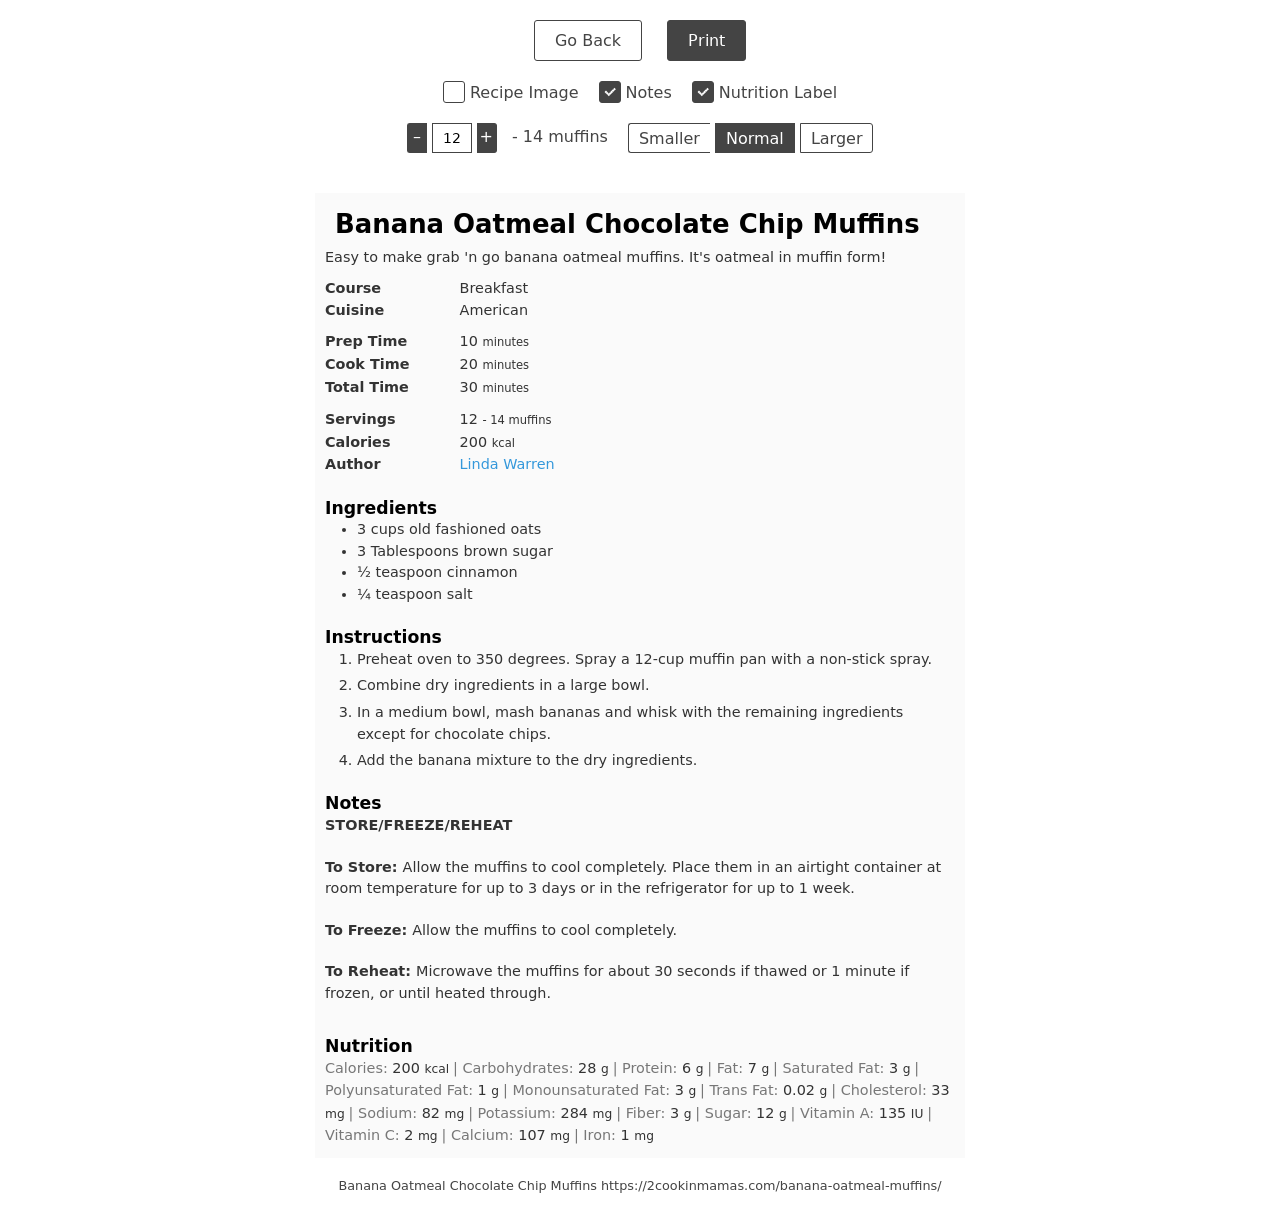How can I start building this website with HTML from the ground up? To start building a website with HTML from scratch, you'll need to understand the basic structure of an HTML document, which includes doctype declaration, html tags, head section, and body section. Here’s a simple template to get you started:

<!DOCTYPE html>
<html>
<head>
    <title>Your Website Title</title>
</head>
<body>
    <h1>Welcome to My Website</h1>
    <p>This is a paragraph of text to demonstrate the body content.</p>
</body>
</html>

This basic structure lays the foundation of your webpage. You can expand it by adding more HTML elements like images, links, lists, etc., and then style your website with CSS. 